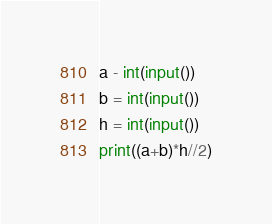Convert code to text. <code><loc_0><loc_0><loc_500><loc_500><_Python_>a - int(input())
b = int(input())
h = int(input())
print((a+b)*h//2)</code> 